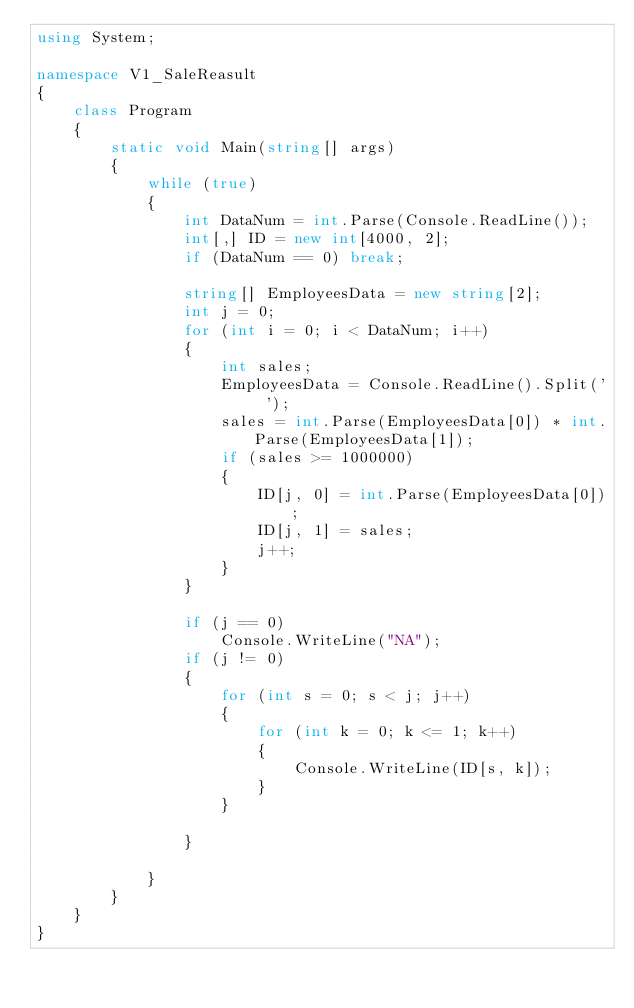<code> <loc_0><loc_0><loc_500><loc_500><_C#_>using System;

namespace V1_SaleReasult
{
    class Program
    {
        static void Main(string[] args)
        {
            while (true)
            {
                int DataNum = int.Parse(Console.ReadLine());
                int[,] ID = new int[4000, 2];
                if (DataNum == 0) break;

                string[] EmployeesData = new string[2];
                int j = 0;
                for (int i = 0; i < DataNum; i++)
                {
                    int sales;
                    EmployeesData = Console.ReadLine().Split(' ');
                    sales = int.Parse(EmployeesData[0]) * int.Parse(EmployeesData[1]);
                    if (sales >= 1000000)
                    {
                        ID[j, 0] = int.Parse(EmployeesData[0]);
                        ID[j, 1] = sales;
                        j++;
                    }
                }

                if (j == 0)
                    Console.WriteLine("NA");
                if (j != 0)
                {
                    for (int s = 0; s < j; j++)
                    {
                        for (int k = 0; k <= 1; k++)
                        {
                            Console.WriteLine(ID[s, k]);
                        }
                    }

                }

            }
        }
    }
}</code> 